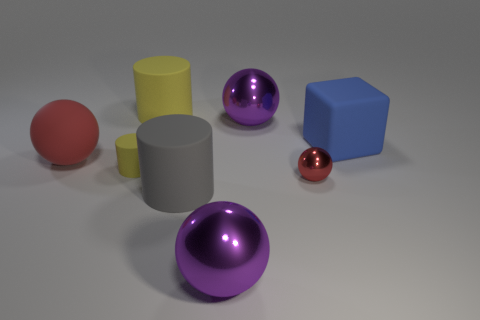Add 1 big yellow things. How many objects exist? 9 Subtract all tiny rubber cylinders. How many cylinders are left? 2 Subtract all blocks. How many objects are left? 7 Subtract all yellow cylinders. How many cylinders are left? 1 Subtract 1 balls. How many balls are left? 3 Subtract all green spheres. Subtract all yellow blocks. How many spheres are left? 4 Subtract all blue balls. How many gray blocks are left? 0 Subtract all blue cubes. Subtract all cubes. How many objects are left? 6 Add 3 big yellow things. How many big yellow things are left? 4 Add 4 large objects. How many large objects exist? 10 